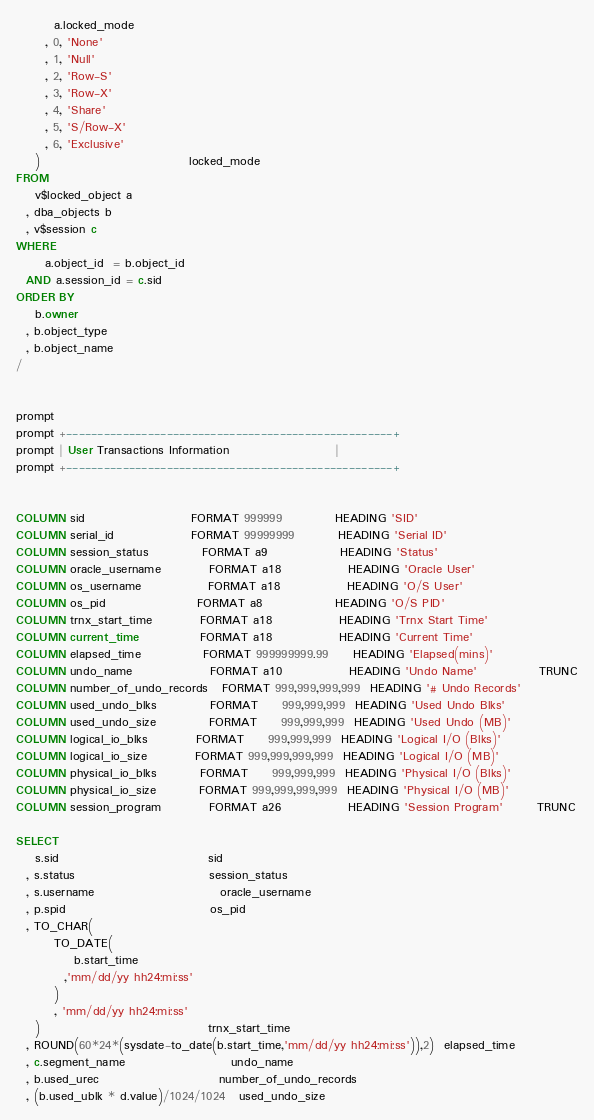Convert code to text. <code><loc_0><loc_0><loc_500><loc_500><_SQL_>        a.locked_mode
      , 0, 'None'
      , 1, 'Null'
      , 2, 'Row-S'
      , 3, 'Row-X'
      , 4, 'Share'
      , 5, 'S/Row-X'
      , 6, 'Exclusive'
    )                               locked_mode
FROM
    v$locked_object a
  , dba_objects b
  , v$session c
WHERE
      a.object_id  = b.object_id
  AND a.session_id = c.sid
ORDER BY
    b.owner
  , b.object_type
  , b.object_name
/


prompt 
prompt +----------------------------------------------------+
prompt | User Transactions Information                      |
prompt +----------------------------------------------------+


COLUMN sid                      FORMAT 999999           HEADING 'SID'
COLUMN serial_id                FORMAT 99999999         HEADING 'Serial ID'
COLUMN session_status           FORMAT a9               HEADING 'Status'
COLUMN oracle_username          FORMAT a18              HEADING 'Oracle User'
COLUMN os_username              FORMAT a18              HEADING 'O/S User'
COLUMN os_pid                   FORMAT a8               HEADING 'O/S PID'
COLUMN trnx_start_time          FORMAT a18              HEADING 'Trnx Start Time'
COLUMN current_time             FORMAT a18              HEADING 'Current Time'
COLUMN elapsed_time             FORMAT 999999999.99     HEADING 'Elapsed(mins)'
COLUMN undo_name                FORMAT a10              HEADING 'Undo Name'             TRUNC
COLUMN number_of_undo_records   FORMAT 999,999,999,999  HEADING '# Undo Records'
COLUMN used_undo_blks           FORMAT     999,999,999  HEADING 'Used Undo Blks' 
COLUMN used_undo_size           FORMAT     999,999,999  HEADING 'Used Undo (MB)'
COLUMN logical_io_blks          FORMAT     999,999,999  HEADING 'Logical I/O (Blks)'
COLUMN logical_io_size          FORMAT 999,999,999,999  HEADING 'Logical I/O (MB)' 
COLUMN physical_io_blks         FORMAT     999,999,999  HEADING 'Physical I/O (Blks)'
COLUMN physical_io_size         FORMAT 999,999,999,999  HEADING 'Physical I/O (MB)'
COLUMN session_program          FORMAT a26              HEADING 'Session Program'       TRUNC

SELECT
    s.sid                               sid
  , s.status                            session_status
  , s.username                          oracle_username
  , p.spid                              os_pid
  , TO_CHAR(
        TO_DATE(
            b.start_time
          ,'mm/dd/yy hh24:mi:ss'
        )
        , 'mm/dd/yy hh24:mi:ss'
    )                                   trnx_start_time
  , ROUND(60*24*(sysdate-to_date(b.start_time,'mm/dd/yy hh24:mi:ss')),2)  elapsed_time
  , c.segment_name                      undo_name
  , b.used_urec                         number_of_undo_records
  , (b.used_ublk * d.value)/1024/1024   used_undo_size</code> 